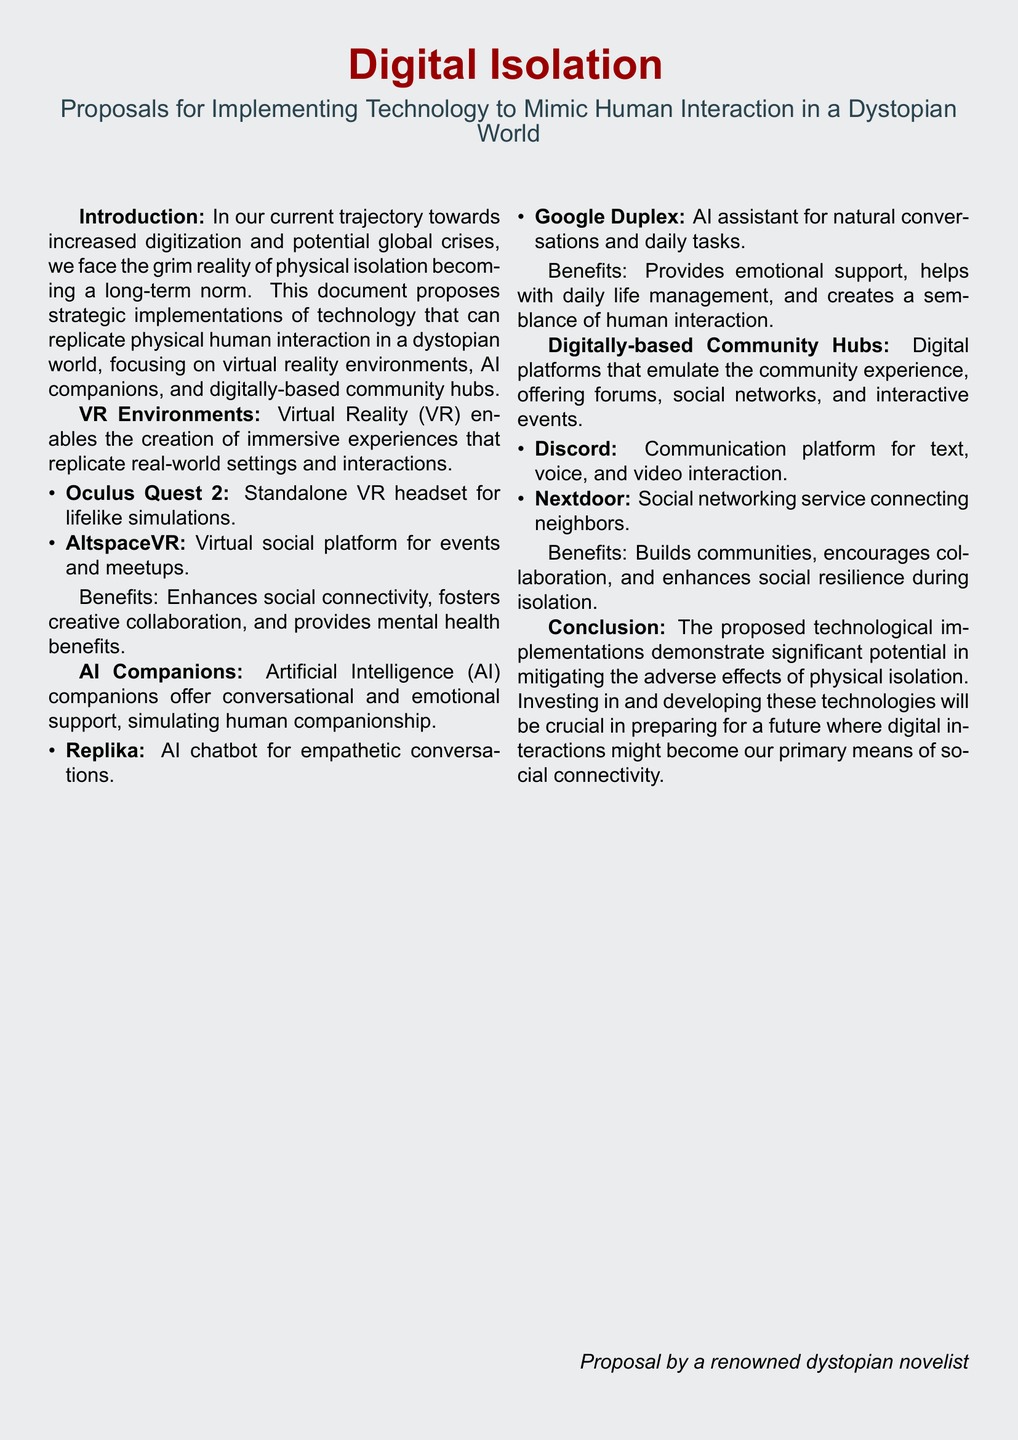what is the title of the document? The title of the document is located at the top section, emphasizing the main theme.
Answer: Digital Isolation what is the main focus of the proposals? The main focus is detailed in the introduction, outlining the primary objective of the document.
Answer: Mimic human interaction which VR headset is mentioned as a suggestion? The document lists specific technologies under the VR Environments section.
Answer: Oculus Quest 2 what is the purpose of AI companions? The purpose of AI companions is explained in the AI Companions section, addressing their function in society.
Answer: Emotional support name one digitally-based community hub mentioned. The document specifies types of community hubs in the relevant section.
Answer: Discord what is one benefit of VR environments listed? The benefits of VR environments are outlined in the corresponding section with specific advantages.
Answer: Enhances social connectivity how many main technological solutions are proposed in the document? The number of proposed solutions can be inferred from the distinct sections dedicated to each solution.
Answer: Three who is the author of the proposal? The author is mentioned at the bottom of the document, indicating their professional background.
Answer: A renowned dystopian novelist 